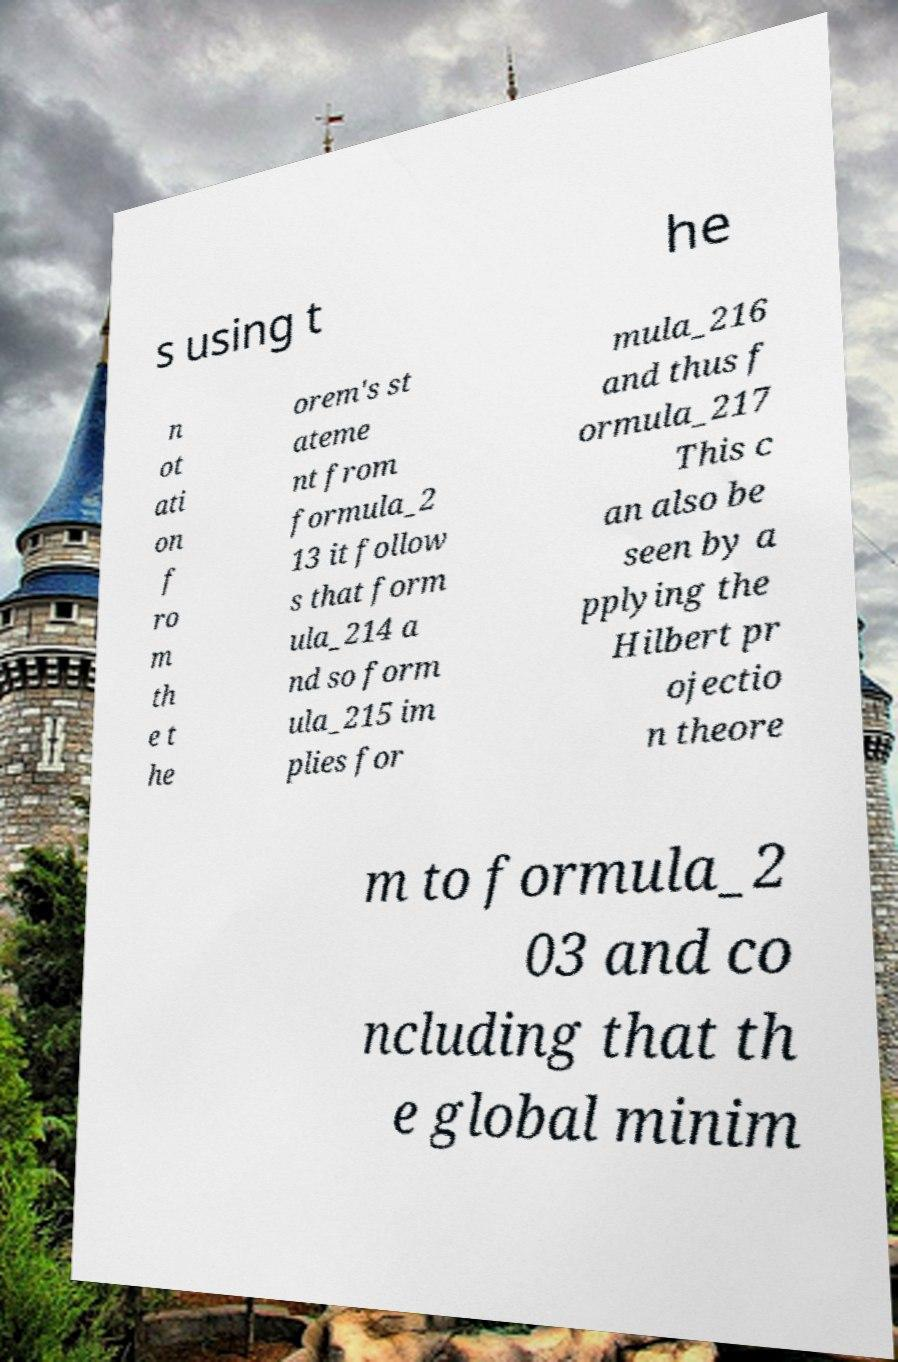Can you read and provide the text displayed in the image?This photo seems to have some interesting text. Can you extract and type it out for me? s using t he n ot ati on f ro m th e t he orem's st ateme nt from formula_2 13 it follow s that form ula_214 a nd so form ula_215 im plies for mula_216 and thus f ormula_217 This c an also be seen by a pplying the Hilbert pr ojectio n theore m to formula_2 03 and co ncluding that th e global minim 